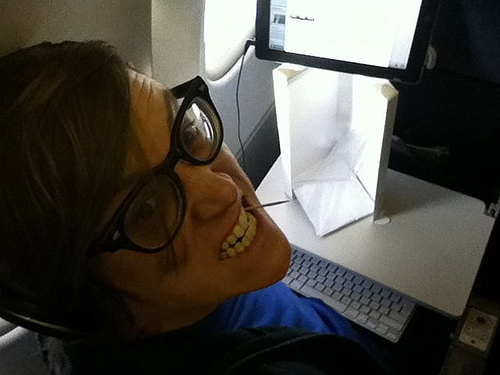Do the table and the glass have a different colors? Yes, the table and the glass have different colors. 